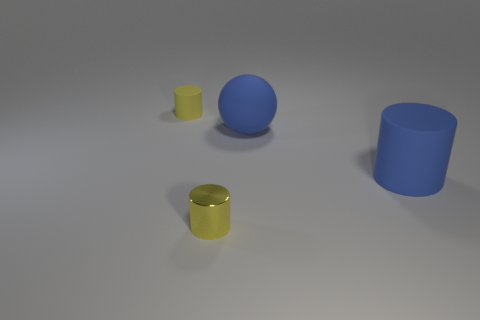Add 4 spheres. How many objects exist? 8 Subtract all cylinders. How many objects are left? 1 Subtract all tiny yellow matte cylinders. Subtract all big rubber cylinders. How many objects are left? 2 Add 4 yellow objects. How many yellow objects are left? 6 Add 4 tiny red balls. How many tiny red balls exist? 4 Subtract 0 cyan cylinders. How many objects are left? 4 